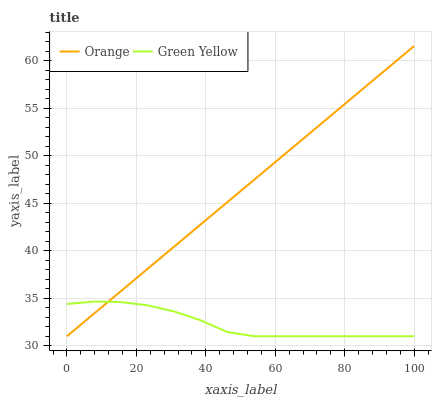Does Green Yellow have the minimum area under the curve?
Answer yes or no. Yes. Does Orange have the maximum area under the curve?
Answer yes or no. Yes. Does Green Yellow have the maximum area under the curve?
Answer yes or no. No. Is Orange the smoothest?
Answer yes or no. Yes. Is Green Yellow the roughest?
Answer yes or no. Yes. Is Green Yellow the smoothest?
Answer yes or no. No. Does Orange have the highest value?
Answer yes or no. Yes. Does Green Yellow have the highest value?
Answer yes or no. No. Does Green Yellow intersect Orange?
Answer yes or no. Yes. Is Green Yellow less than Orange?
Answer yes or no. No. Is Green Yellow greater than Orange?
Answer yes or no. No. 